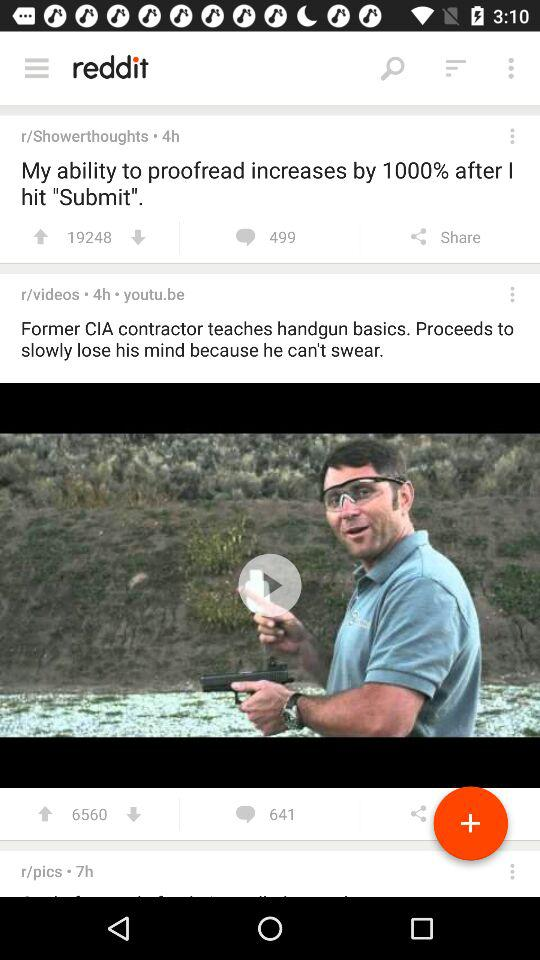What is the number of comments for the post "My ability to proofread increases by 1000% after I hit "submit""? The number of comments for the post is 499. 